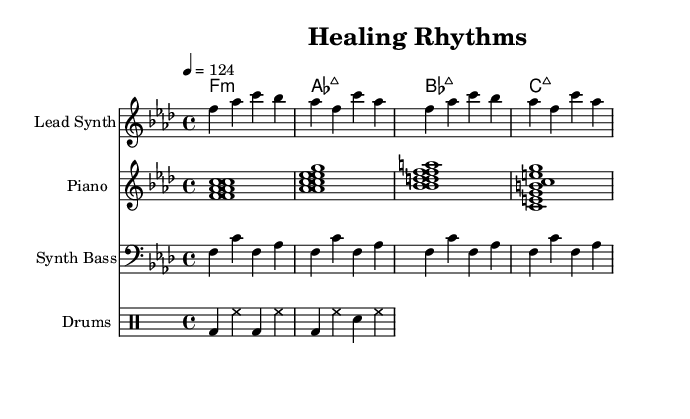What is the key signature of this music? The key signature is F minor, indicated by four flats in the key signature area.
Answer: F minor What is the time signature of this music? The time signature is 4/4, which is indicated at the beginning of the score.
Answer: 4/4 What is the tempo marking of this piece? The tempo marking is 124 beats per minute, as indicated by the tempo instruction "4 = 124".
Answer: 124 How many measures are in the lead synth part? The lead synth part has 8 measures, as determined by counting the groups of notes in the staff.
Answer: 8 What chord appears first in the piano chords? The first chord in the piano chords is F minor, which is indicated by the notation "f1:m".
Answer: F minor What type of percussion is primarily used in this score? The primary percussion used in this score is drums, specifically a kick drum and snare, which are indicated in the drum patterns.
Answer: Drums Which two chords appear consecutively after the first measure in the piano part? The two chords that appear consecutively after the first measure in the piano part are A flat major and B flat major, as seen in the chord progression.
Answer: A flat major and B flat major 